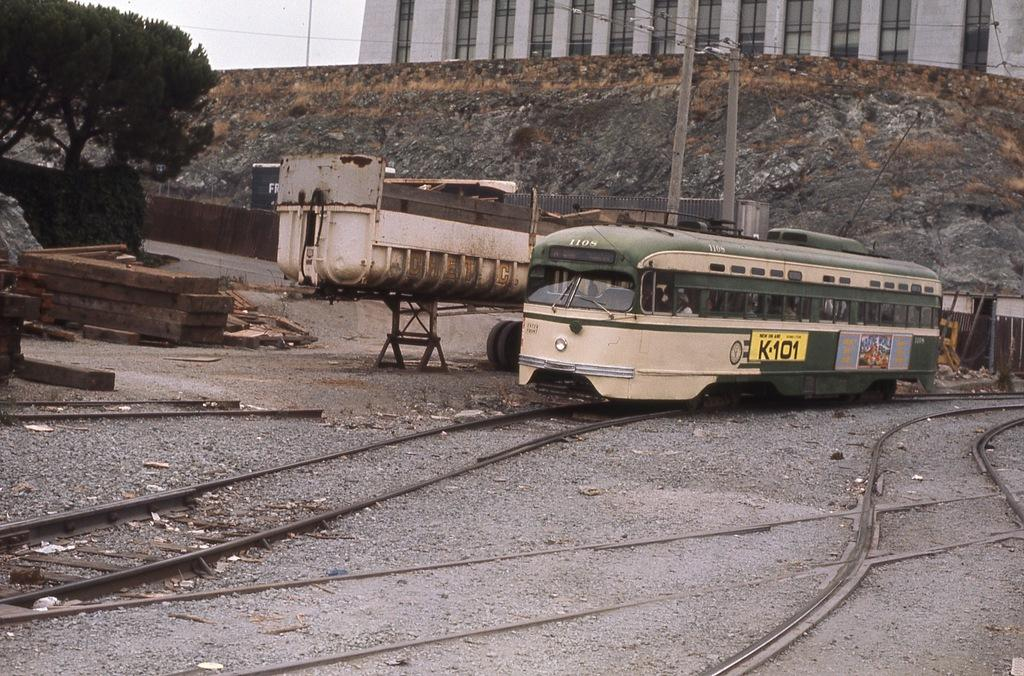<image>
Present a compact description of the photo's key features. a sign on a bus that says K101 on it 